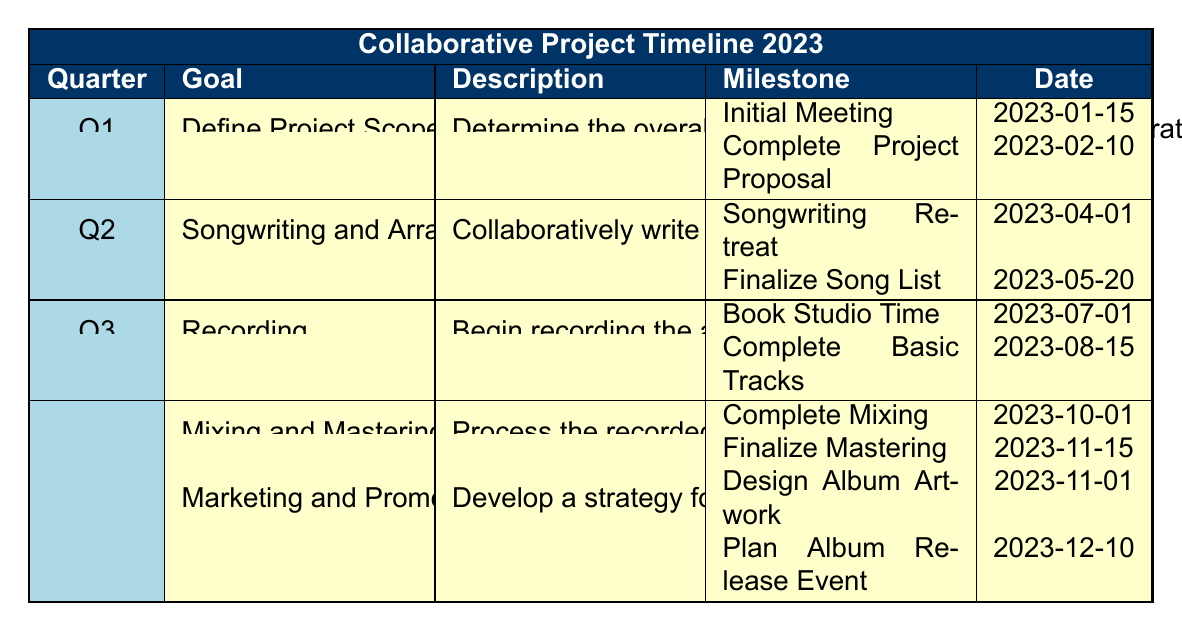What is the goal for Q1? The goal listed for Q1 in the table is "Define Project Scope".
Answer: Define Project Scope When is the initial meeting scheduled? The initial meeting is scheduled for January 15, 2023, as shown under the milestones for Q1.
Answer: 2023-01-15 Who is responsible for finalizing the song list? The responsible party for finalizing the song list is the "Lead songwriter" according to the Q2 milestones.
Answer: Lead songwriter What is the total number of milestones listed for Q4? There are four milestones mentioned for Q4: two for Mixing and Mastering and two for Marketing and Promotion, which adds up to four.
Answer: 4 Did all musicians participate in the songwriting retreat? Yes, the milestone for the songwriting retreat indicates that it is the responsibility of "All musicians".
Answer: Yes Which month has the milestone "Design Album Artwork"? The milestone "Design Album Artwork" is scheduled for November, as per the Q4 goals and milestones section.
Answer: November When does the final mastering need to be completed? The final mastering is scheduled to be completed by November 15, 2023, according to Q4 milestones.
Answer: 2023-11-15 What is the interval between booking studio time and completing basic tracks? The booking studio time is on July 1, and the completion of basic tracks is by August 15, which yields an interval of 1 month and 15 days.
Answer: 1 month and 15 days Is there a milestone in Q3 before the completion of basic tracks? Yes, the milestone "Book Studio Time" in Q3 comes before "Complete Basic Tracks".
Answer: Yes What is the order of goals from Q1 to Q4? The order of goals is: Q1 - Define Project Scope, Q2 - Songwriting and Arrangement, Q3 - Recording, Q4 - Mixing and Mastering, and Marketing and Promotion.
Answer: Define Project Scope, Songwriting and Arrangement, Recording, Mixing and Mastering, Marketing and Promotion 